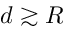<formula> <loc_0><loc_0><loc_500><loc_500>d \gtrsim R</formula> 